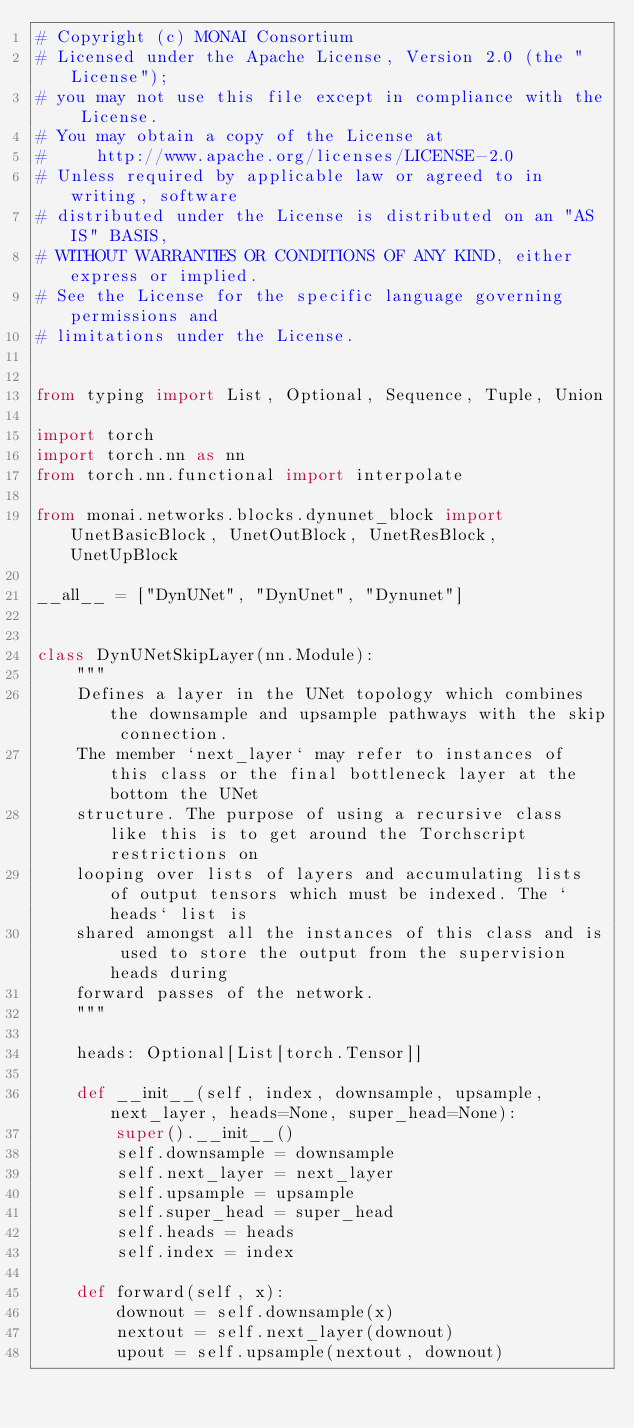Convert code to text. <code><loc_0><loc_0><loc_500><loc_500><_Python_># Copyright (c) MONAI Consortium
# Licensed under the Apache License, Version 2.0 (the "License");
# you may not use this file except in compliance with the License.
# You may obtain a copy of the License at
#     http://www.apache.org/licenses/LICENSE-2.0
# Unless required by applicable law or agreed to in writing, software
# distributed under the License is distributed on an "AS IS" BASIS,
# WITHOUT WARRANTIES OR CONDITIONS OF ANY KIND, either express or implied.
# See the License for the specific language governing permissions and
# limitations under the License.


from typing import List, Optional, Sequence, Tuple, Union

import torch
import torch.nn as nn
from torch.nn.functional import interpolate

from monai.networks.blocks.dynunet_block import UnetBasicBlock, UnetOutBlock, UnetResBlock, UnetUpBlock

__all__ = ["DynUNet", "DynUnet", "Dynunet"]


class DynUNetSkipLayer(nn.Module):
    """
    Defines a layer in the UNet topology which combines the downsample and upsample pathways with the skip connection.
    The member `next_layer` may refer to instances of this class or the final bottleneck layer at the bottom the UNet
    structure. The purpose of using a recursive class like this is to get around the Torchscript restrictions on
    looping over lists of layers and accumulating lists of output tensors which must be indexed. The `heads` list is
    shared amongst all the instances of this class and is used to store the output from the supervision heads during
    forward passes of the network.
    """

    heads: Optional[List[torch.Tensor]]

    def __init__(self, index, downsample, upsample, next_layer, heads=None, super_head=None):
        super().__init__()
        self.downsample = downsample
        self.next_layer = next_layer
        self.upsample = upsample
        self.super_head = super_head
        self.heads = heads
        self.index = index

    def forward(self, x):
        downout = self.downsample(x)
        nextout = self.next_layer(downout)
        upout = self.upsample(nextout, downout)</code> 